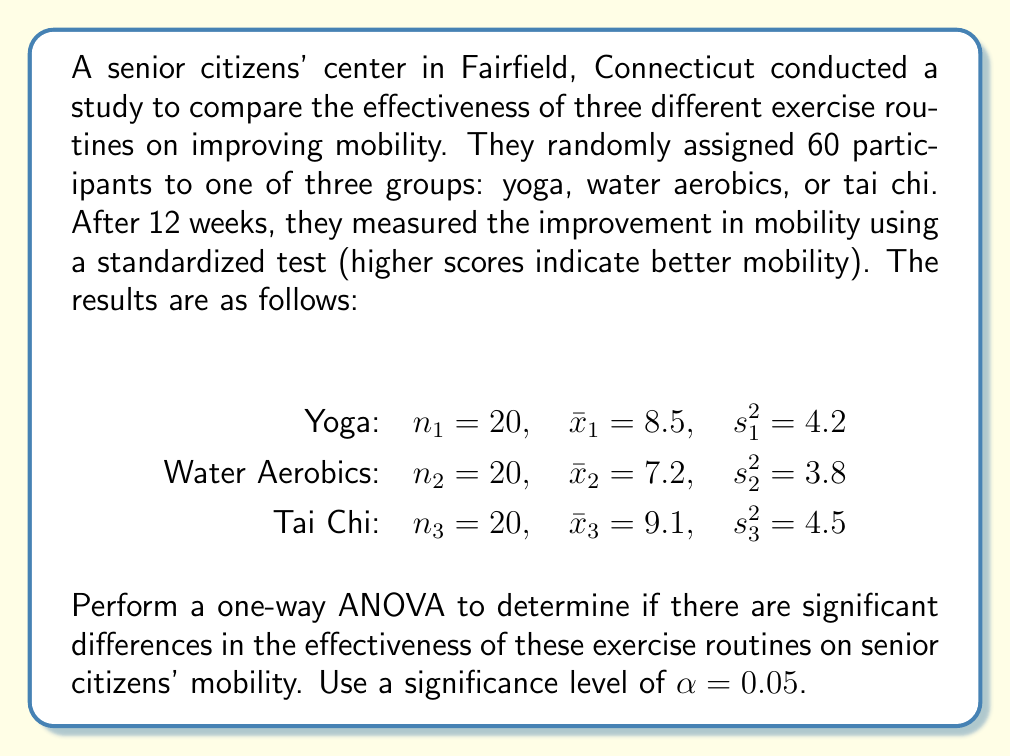Could you help me with this problem? To perform a one-way ANOVA, we need to follow these steps:

1. Calculate the sum of squares between groups (SSB)
2. Calculate the sum of squares within groups (SSW)
3. Calculate the total sum of squares (SST)
4. Compute the degrees of freedom (df)
5. Calculate the mean squares
6. Compute the F-statistic
7. Compare the F-statistic to the critical F-value

Step 1: Calculate SSB
First, we need to find the grand mean:
$$\bar{x} = \frac{20(8.5) + 20(7.2) + 20(9.1)}{60} = 8.27$$

Now, we can calculate SSB:
$$SSB = \sum_{i=1}^k n_i(\bar{x}_i - \bar{x})^2$$
$$SSB = 20(8.5 - 8.27)^2 + 20(7.2 - 8.27)^2 + 20(9.1 - 8.27)^2 = 36.98$$

Step 2: Calculate SSW
$$SSW = \sum_{i=1}^k (n_i - 1)s_i^2$$
$$SSW = 19(4.2) + 19(3.8) + 19(4.5) = 237.5$$

Step 3: Calculate SST
$$SST = SSB + SSW = 36.98 + 237.5 = 274.48$$

Step 4: Compute degrees of freedom
$$df_{between} = k - 1 = 3 - 1 = 2$$
$$df_{within} = N - k = 60 - 3 = 57$$
$$df_{total} = N - 1 = 60 - 1 = 59$$

Step 5: Calculate mean squares
$$MS_{between} = \frac{SSB}{df_{between}} = \frac{36.98}{2} = 18.49$$
$$MS_{within} = \frac{SSW}{df_{within}} = \frac{237.5}{57} = 4.17$$

Step 6: Compute F-statistic
$$F = \frac{MS_{between}}{MS_{within}} = \frac{18.49}{4.17} = 4.43$$

Step 7: Compare F-statistic to critical F-value
The critical F-value for $\alpha = 0.05$, $df_{between} = 2$, and $df_{within} = 57$ is approximately 3.16.

Since our calculated F-statistic (4.43) is greater than the critical F-value (3.16), we reject the null hypothesis.
Answer: The one-way ANOVA results in an F-statistic of 4.43, which is greater than the critical F-value of 3.16 at $\alpha = 0.05$. Therefore, we reject the null hypothesis and conclude that there are significant differences in the effectiveness of yoga, water aerobics, and tai chi on senior citizens' mobility in Fairfield, Connecticut. 